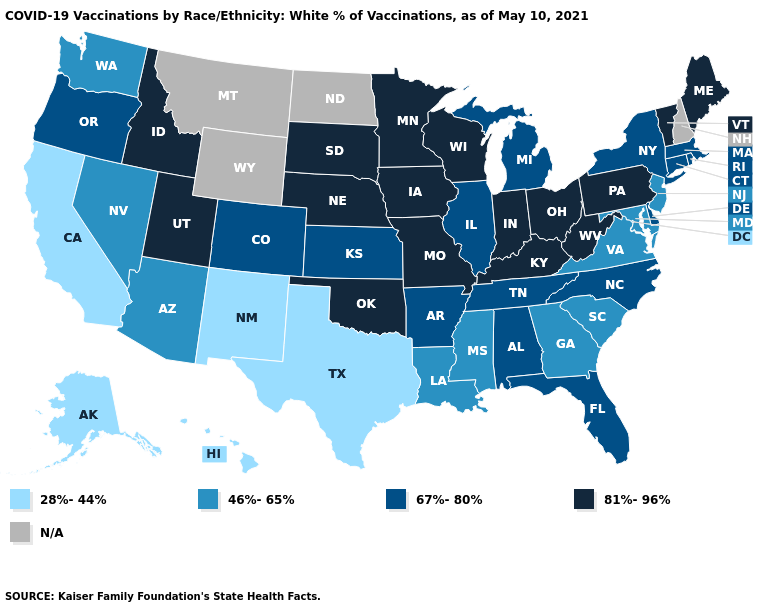Among the states that border Connecticut , which have the lowest value?
Be succinct. Massachusetts, New York, Rhode Island. Which states have the lowest value in the USA?
Short answer required. Alaska, California, Hawaii, New Mexico, Texas. What is the highest value in the USA?
Keep it brief. 81%-96%. How many symbols are there in the legend?
Quick response, please. 5. Does Arizona have the highest value in the West?
Give a very brief answer. No. Among the states that border Kansas , which have the lowest value?
Be succinct. Colorado. Name the states that have a value in the range 46%-65%?
Concise answer only. Arizona, Georgia, Louisiana, Maryland, Mississippi, Nevada, New Jersey, South Carolina, Virginia, Washington. Which states have the highest value in the USA?
Quick response, please. Idaho, Indiana, Iowa, Kentucky, Maine, Minnesota, Missouri, Nebraska, Ohio, Oklahoma, Pennsylvania, South Dakota, Utah, Vermont, West Virginia, Wisconsin. What is the value of Wisconsin?
Short answer required. 81%-96%. Does Utah have the highest value in the West?
Keep it brief. Yes. Name the states that have a value in the range 46%-65%?
Give a very brief answer. Arizona, Georgia, Louisiana, Maryland, Mississippi, Nevada, New Jersey, South Carolina, Virginia, Washington. Name the states that have a value in the range 81%-96%?
Keep it brief. Idaho, Indiana, Iowa, Kentucky, Maine, Minnesota, Missouri, Nebraska, Ohio, Oklahoma, Pennsylvania, South Dakota, Utah, Vermont, West Virginia, Wisconsin. What is the highest value in the USA?
Write a very short answer. 81%-96%. Does the map have missing data?
Be succinct. Yes. Name the states that have a value in the range 81%-96%?
Answer briefly. Idaho, Indiana, Iowa, Kentucky, Maine, Minnesota, Missouri, Nebraska, Ohio, Oklahoma, Pennsylvania, South Dakota, Utah, Vermont, West Virginia, Wisconsin. 